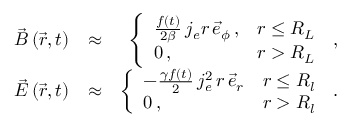<formula> <loc_0><loc_0><loc_500><loc_500>\begin{array} { r l r } { \vec { B } \left ( \vec { r } , t \right ) } & { \approx } & { \left \{ \begin{array} { l l } { \frac { f ( t ) } { 2 \beta } \, j _ { e } r \, \vec { e } _ { \phi } \, , } & { r \leq R _ { L } } \\ { 0 \, , } & { r > R _ { L } } \end{array} \, , } \\ { \vec { E } \left ( \vec { r } , t \right ) } & { \approx } & { \left \{ \begin{array} { l l } { - \frac { \gamma f ( t ) } { 2 } \, j _ { e } ^ { 2 } \, r \, \vec { e } _ { r } } & { r \leq R _ { l } } \\ { 0 \, , } & { r > R _ { l } } \end{array} \, . } \end{array}</formula> 